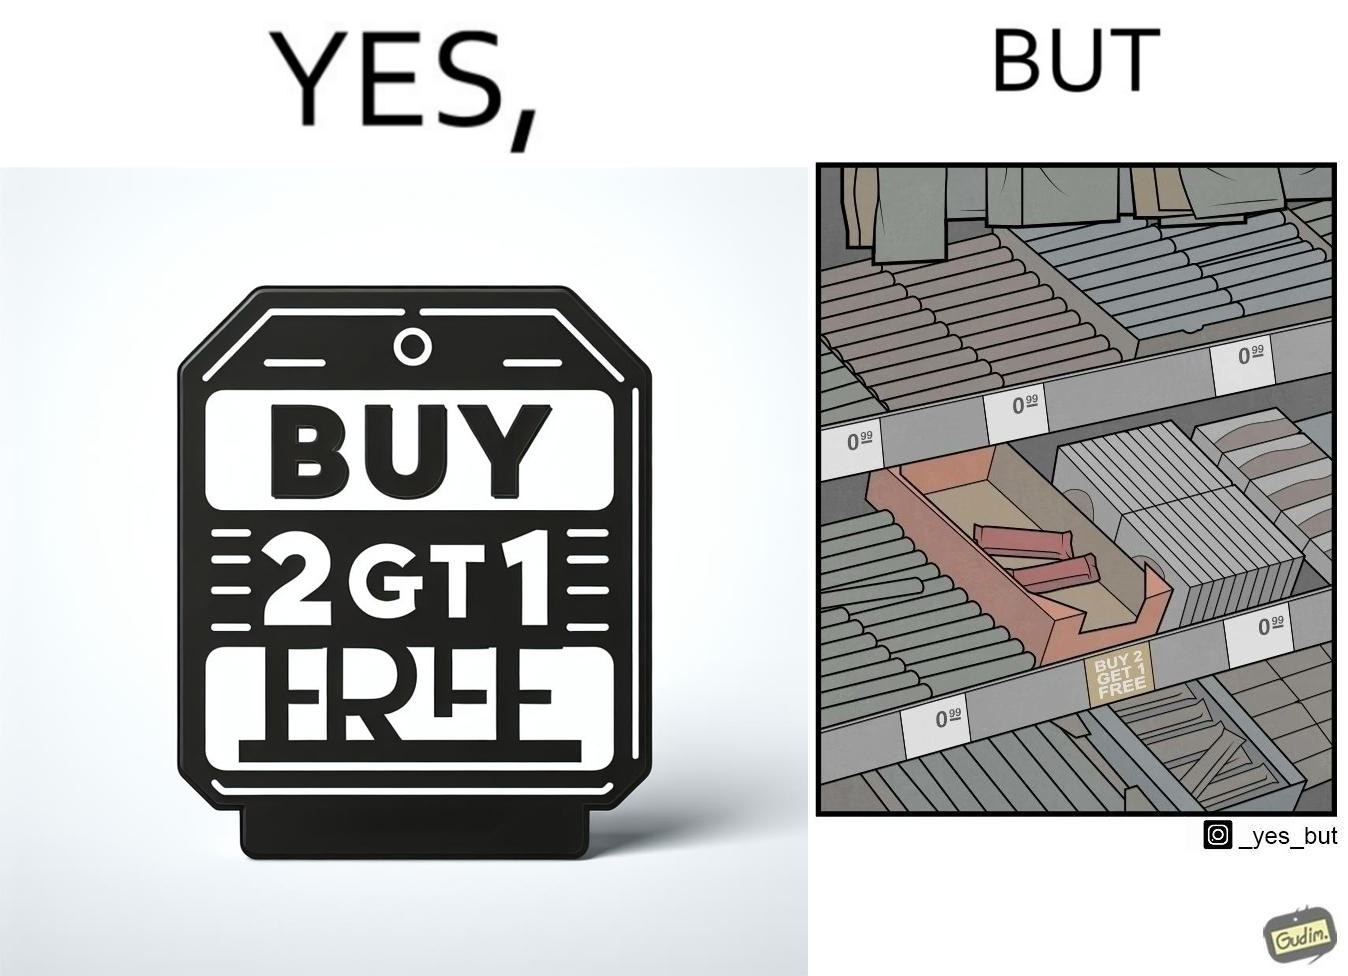Provide a description of this image. The image is funny because while there is an offer that lets the buyer have a free item if they buy two items of the product, there is only two units left which means that the buyer won't get the free unit. 